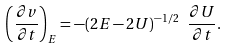<formula> <loc_0><loc_0><loc_500><loc_500>\left ( \frac { \partial v } { \partial t } \right ) _ { E } = - ( 2 E - 2 U ) ^ { - 1 / 2 } \ \frac { \partial U } { \partial t } .</formula> 